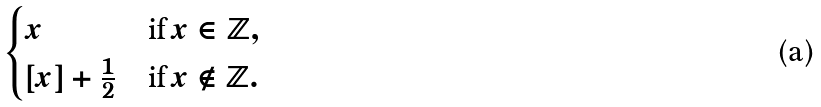Convert formula to latex. <formula><loc_0><loc_0><loc_500><loc_500>\begin{cases} x & \text {if\,} x \in \mathbb { Z } , \\ [ x ] + \frac { 1 } { 2 } & \text {if\,} x \notin \mathbb { Z } . \end{cases}</formula> 